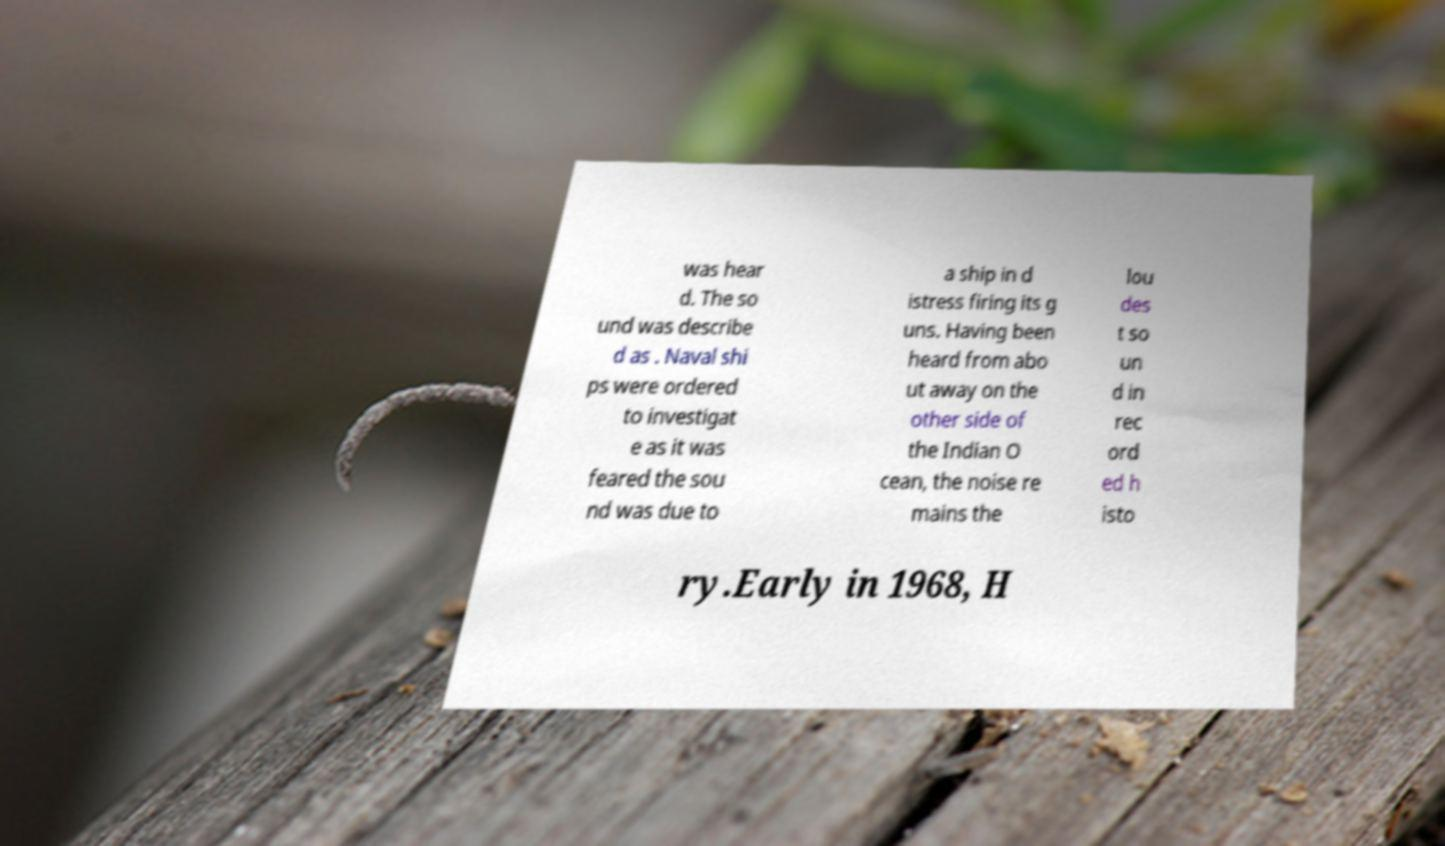What messages or text are displayed in this image? I need them in a readable, typed format. was hear d. The so und was describe d as . Naval shi ps were ordered to investigat e as it was feared the sou nd was due to a ship in d istress firing its g uns. Having been heard from abo ut away on the other side of the Indian O cean, the noise re mains the lou des t so un d in rec ord ed h isto ry.Early in 1968, H 